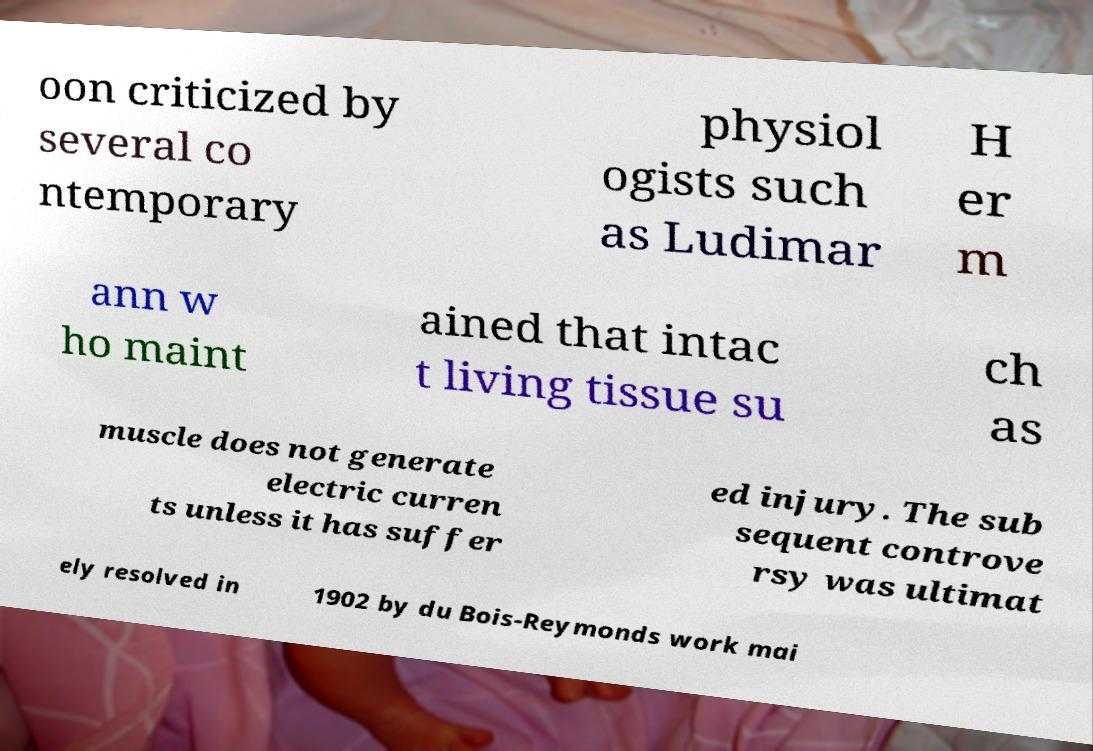What messages or text are displayed in this image? I need them in a readable, typed format. oon criticized by several co ntemporary physiol ogists such as Ludimar H er m ann w ho maint ained that intac t living tissue su ch as muscle does not generate electric curren ts unless it has suffer ed injury. The sub sequent controve rsy was ultimat ely resolved in 1902 by du Bois-Reymonds work mai 